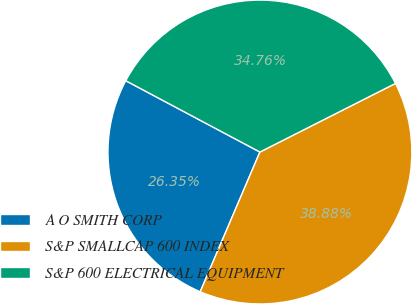Convert chart. <chart><loc_0><loc_0><loc_500><loc_500><pie_chart><fcel>A O SMITH CORP<fcel>S&P SMALLCAP 600 INDEX<fcel>S&P 600 ELECTRICAL EQUIPMENT<nl><fcel>26.35%<fcel>38.88%<fcel>34.76%<nl></chart> 